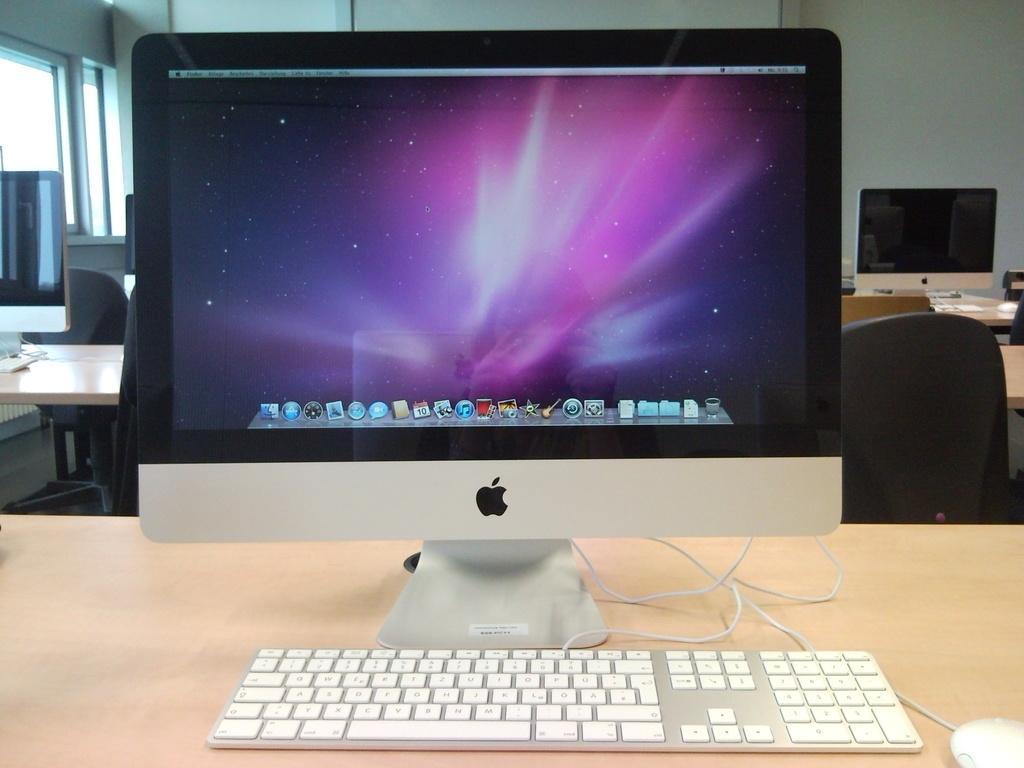How would you summarize this image in a sentence or two? We can see chairs and tables on the table there are monitors,keyboard,mouse. On the background we can see wall,glass window. 